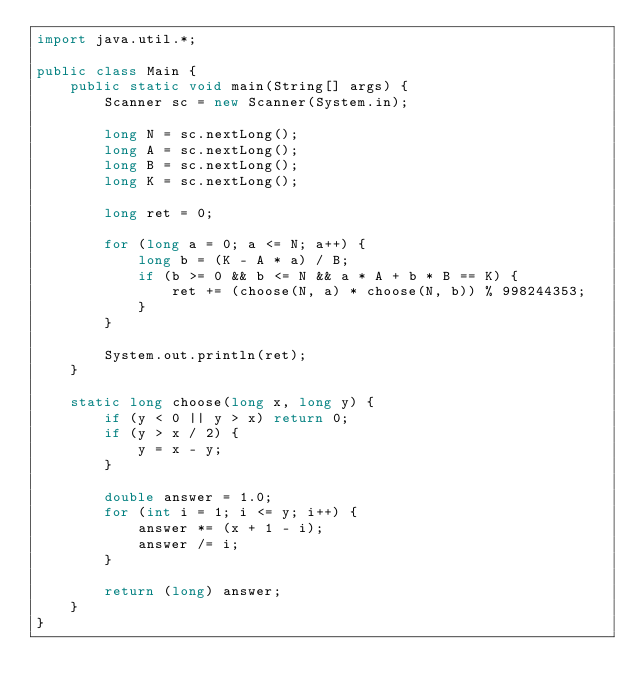Convert code to text. <code><loc_0><loc_0><loc_500><loc_500><_Java_>import java.util.*;

public class Main {
    public static void main(String[] args) {
        Scanner sc = new Scanner(System.in);

        long N = sc.nextLong();
        long A = sc.nextLong();
        long B = sc.nextLong();
        long K = sc.nextLong();

        long ret = 0;

        for (long a = 0; a <= N; a++) {
            long b = (K - A * a) / B;
            if (b >= 0 && b <= N && a * A + b * B == K) {
                ret += (choose(N, a) * choose(N, b)) % 998244353;
            }
        }

        System.out.println(ret);
    }

    static long choose(long x, long y) {
        if (y < 0 || y > x) return 0;
        if (y > x / 2) {
            y = x - y;
        }

        double answer = 1.0;
        for (int i = 1; i <= y; i++) {
            answer *= (x + 1 - i);
            answer /= i;
        }

        return (long) answer;
    }
}</code> 